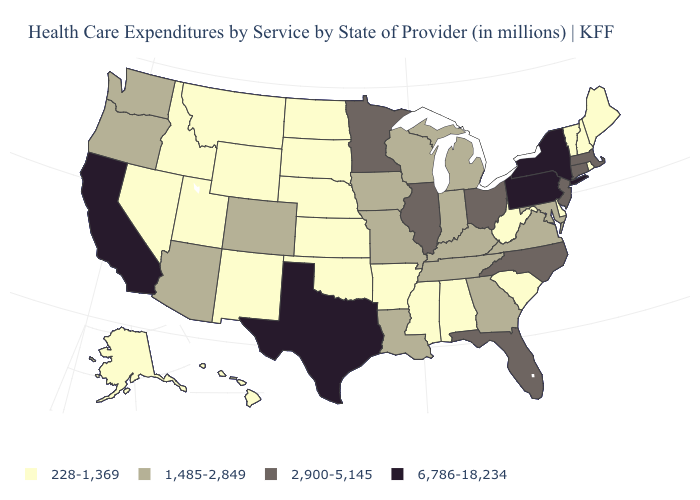Among the states that border Maryland , which have the highest value?
Write a very short answer. Pennsylvania. Name the states that have a value in the range 6,786-18,234?
Write a very short answer. California, New York, Pennsylvania, Texas. Does the map have missing data?
Keep it brief. No. What is the value of Delaware?
Quick response, please. 228-1,369. Name the states that have a value in the range 1,485-2,849?
Be succinct. Arizona, Colorado, Georgia, Indiana, Iowa, Kentucky, Louisiana, Maryland, Michigan, Missouri, Oregon, Tennessee, Virginia, Washington, Wisconsin. Name the states that have a value in the range 6,786-18,234?
Short answer required. California, New York, Pennsylvania, Texas. What is the value of Hawaii?
Keep it brief. 228-1,369. Which states have the lowest value in the USA?
Keep it brief. Alabama, Alaska, Arkansas, Delaware, Hawaii, Idaho, Kansas, Maine, Mississippi, Montana, Nebraska, Nevada, New Hampshire, New Mexico, North Dakota, Oklahoma, Rhode Island, South Carolina, South Dakota, Utah, Vermont, West Virginia, Wyoming. What is the lowest value in the USA?
Short answer required. 228-1,369. Name the states that have a value in the range 2,900-5,145?
Quick response, please. Connecticut, Florida, Illinois, Massachusetts, Minnesota, New Jersey, North Carolina, Ohio. What is the value of Nevada?
Concise answer only. 228-1,369. Among the states that border Ohio , does Michigan have the lowest value?
Write a very short answer. No. Does New Hampshire have the highest value in the Northeast?
Quick response, please. No. How many symbols are there in the legend?
Quick response, please. 4. What is the value of Wisconsin?
Be succinct. 1,485-2,849. 